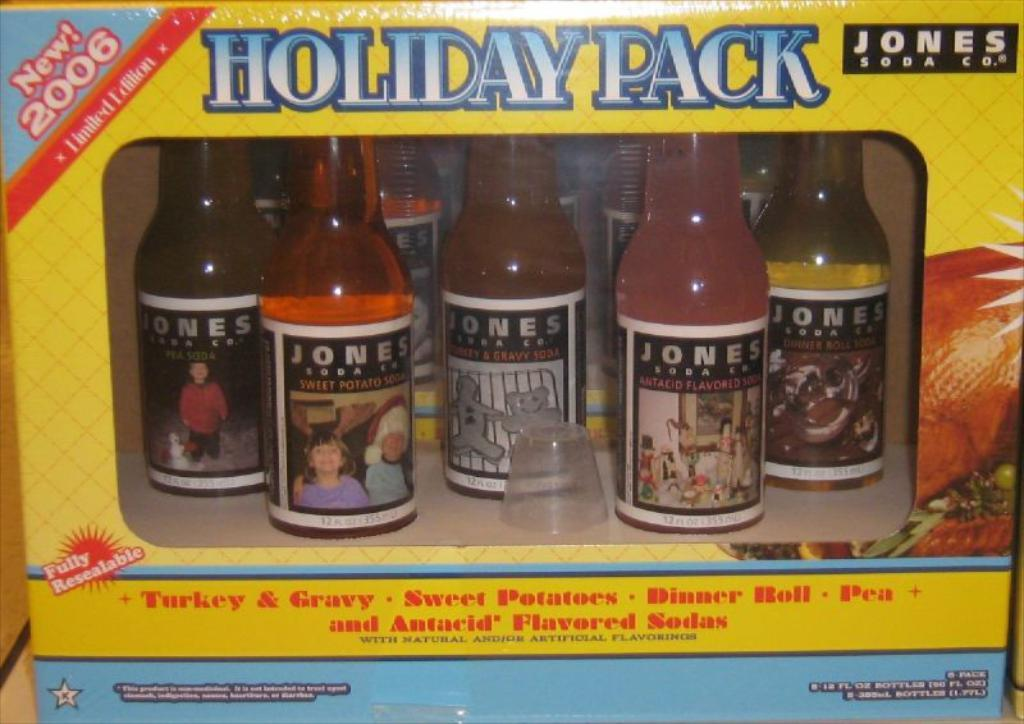<image>
Give a short and clear explanation of the subsequent image. a yellow box Holiday Pack of Jones Soda 